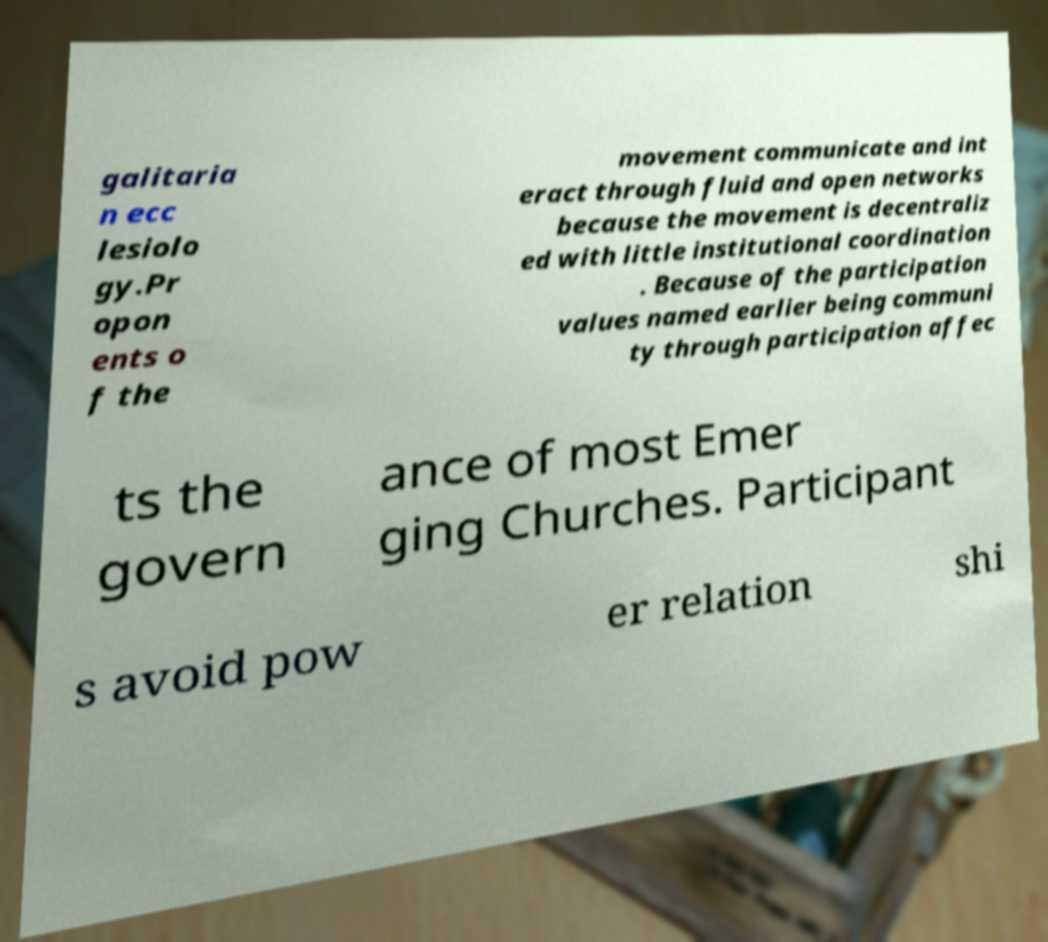I need the written content from this picture converted into text. Can you do that? galitaria n ecc lesiolo gy.Pr opon ents o f the movement communicate and int eract through fluid and open networks because the movement is decentraliz ed with little institutional coordination . Because of the participation values named earlier being communi ty through participation affec ts the govern ance of most Emer ging Churches. Participant s avoid pow er relation shi 